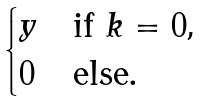<formula> <loc_0><loc_0><loc_500><loc_500>\begin{cases} y & \text {if $k=0$,} \\ 0 & \text {else.} \end{cases}</formula> 